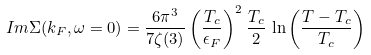<formula> <loc_0><loc_0><loc_500><loc_500>I m \Sigma ( { k _ { F } } , \omega = 0 ) = \frac { 6 \pi ^ { 3 } } { 7 \zeta ( 3 ) } \left ( \frac { T _ { c } } { \epsilon _ { F } } \right ) ^ { 2 } \frac { T _ { c } } { 2 } \, \ln \left ( \frac { T - T _ { c } } { T _ { c } } \right )</formula> 